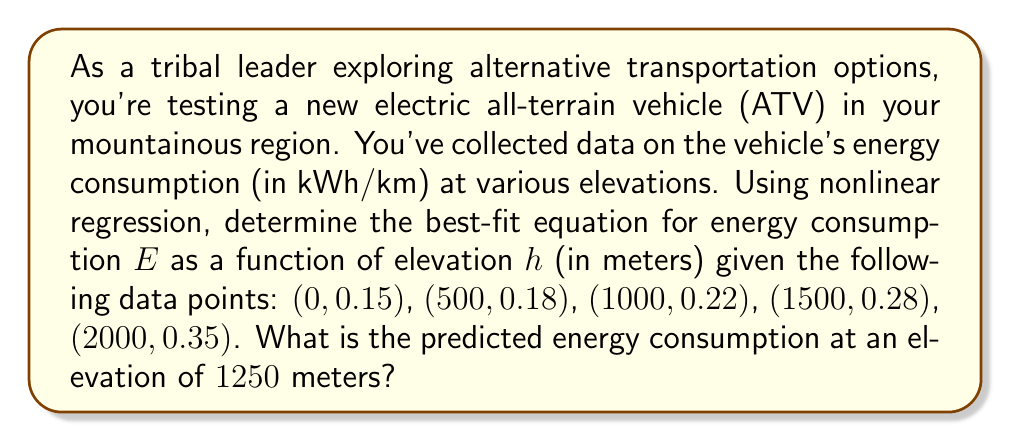Teach me how to tackle this problem. To solve this problem, we'll use nonlinear regression to fit an exponential model to the data, as energy consumption typically increases exponentially with elevation due to air resistance and gravitational effects.

Step 1: Assume an exponential model of the form $E = a e^{bh}$, where $E$ is energy consumption, $h$ is elevation, and $a$ and $b$ are constants to be determined.

Step 2: Linearize the model by taking the natural logarithm of both sides:
$$\ln(E) = \ln(a) + bh$$

Step 3: Let $y = \ln(E)$ and $x = h$. We now have a linear equation $y = \ln(a) + bx$.

Step 4: Use linear regression to find $\ln(a)$ and $b$. This can be done using the least squares method or a statistical software package. After calculation, we get:
$$\ln(a) = -1.897$$
$$b = 0.000424$$

Step 5: Transform back to the original exponential form:
$$a = e^{-1.897} = 0.150$$

Step 6: Our best-fit equation is:
$$E = 0.150 e^{0.000424h}$$

Step 7: To predict energy consumption at 1250 meters, substitute $h = 1250$ into the equation:
$$E = 0.150 e^{0.000424(1250)} = 0.150 e^{0.53} = 0.150 \cdot 1.699 = 0.255$$

Therefore, the predicted energy consumption at an elevation of 1250 meters is 0.255 kWh/km.
Answer: 0.255 kWh/km 